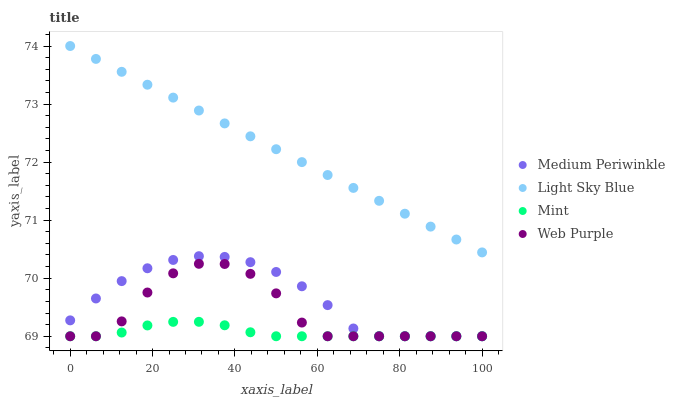Does Mint have the minimum area under the curve?
Answer yes or no. Yes. Does Light Sky Blue have the maximum area under the curve?
Answer yes or no. Yes. Does Web Purple have the minimum area under the curve?
Answer yes or no. No. Does Web Purple have the maximum area under the curve?
Answer yes or no. No. Is Light Sky Blue the smoothest?
Answer yes or no. Yes. Is Web Purple the roughest?
Answer yes or no. Yes. Is Web Purple the smoothest?
Answer yes or no. No. Is Light Sky Blue the roughest?
Answer yes or no. No. Does Mint have the lowest value?
Answer yes or no. Yes. Does Light Sky Blue have the lowest value?
Answer yes or no. No. Does Light Sky Blue have the highest value?
Answer yes or no. Yes. Does Web Purple have the highest value?
Answer yes or no. No. Is Medium Periwinkle less than Light Sky Blue?
Answer yes or no. Yes. Is Light Sky Blue greater than Web Purple?
Answer yes or no. Yes. Does Medium Periwinkle intersect Mint?
Answer yes or no. Yes. Is Medium Periwinkle less than Mint?
Answer yes or no. No. Is Medium Periwinkle greater than Mint?
Answer yes or no. No. Does Medium Periwinkle intersect Light Sky Blue?
Answer yes or no. No. 